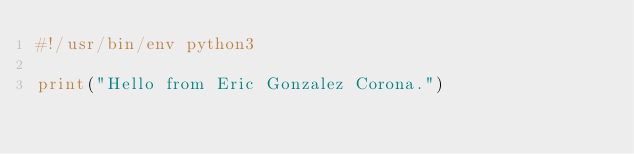Convert code to text. <code><loc_0><loc_0><loc_500><loc_500><_Python_>#!/usr/bin/env python3

print("Hello from Eric Gonzalez Corona.")</code> 